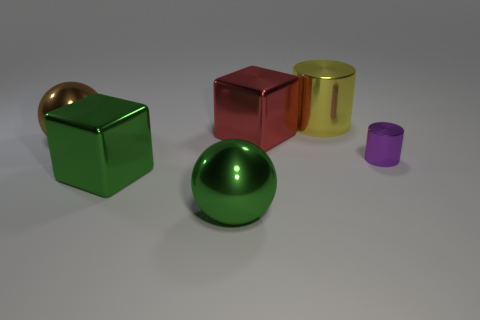What is the shape of the yellow thing that is the same size as the brown object?
Make the answer very short. Cylinder. How big is the purple shiny object?
Ensure brevity in your answer.  Small. What material is the big block that is in front of the large shiny sphere on the left side of the block in front of the brown shiny ball?
Your answer should be compact. Metal. There is a big cylinder that is the same material as the green cube; what color is it?
Give a very brief answer. Yellow. There is a large shiny ball behind the big sphere that is right of the brown object; what number of brown shiny objects are on the right side of it?
Offer a very short reply. 0. What number of objects are small purple shiny cylinders in front of the large brown object or large spheres?
Ensure brevity in your answer.  3. What is the shape of the shiny thing in front of the big cube that is on the left side of the red thing?
Offer a terse response. Sphere. Are there fewer large green cubes that are to the left of the green shiny cube than metallic spheres that are behind the small cylinder?
Your answer should be very brief. Yes. What is the size of the other object that is the same shape as the big yellow object?
Your answer should be compact. Small. Is there any other thing that has the same size as the purple metallic cylinder?
Give a very brief answer. No. 